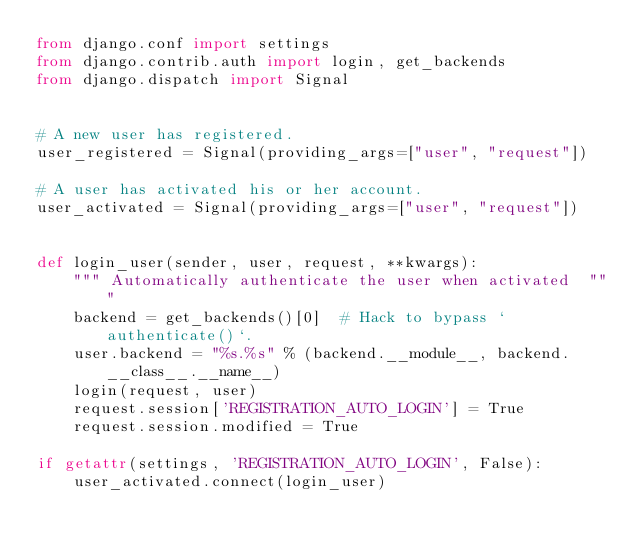<code> <loc_0><loc_0><loc_500><loc_500><_Python_>from django.conf import settings
from django.contrib.auth import login, get_backends
from django.dispatch import Signal


# A new user has registered.
user_registered = Signal(providing_args=["user", "request"])

# A user has activated his or her account.
user_activated = Signal(providing_args=["user", "request"])


def login_user(sender, user, request, **kwargs):
    """ Automatically authenticate the user when activated  """
    backend = get_backends()[0]  # Hack to bypass `authenticate()`.
    user.backend = "%s.%s" % (backend.__module__, backend.__class__.__name__)
    login(request, user)
    request.session['REGISTRATION_AUTO_LOGIN'] = True
    request.session.modified = True

if getattr(settings, 'REGISTRATION_AUTO_LOGIN', False):
    user_activated.connect(login_user)</code> 